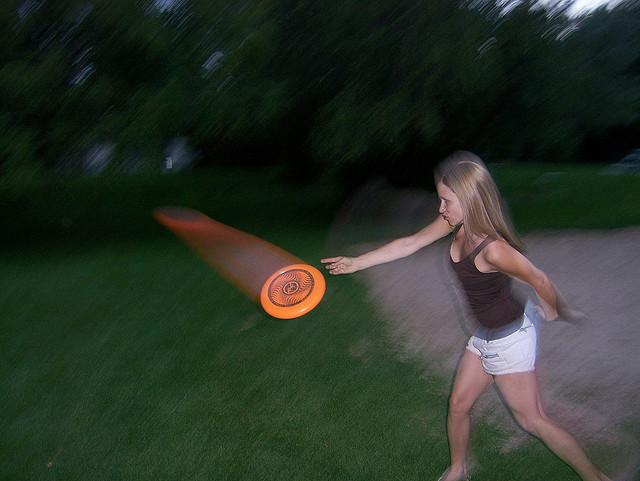How many frisbees are there?
Keep it brief. 1. Is this woman in mid motion catching a frisbee?
Give a very brief answer. Yes. Is the woman throwing or catching the frisbee?
Be succinct. Throwing. Is the girl's hair a natural color?
Write a very short answer. Yes. Is this picture clear?
Keep it brief. No. What color are her shorts?
Write a very short answer. White. 